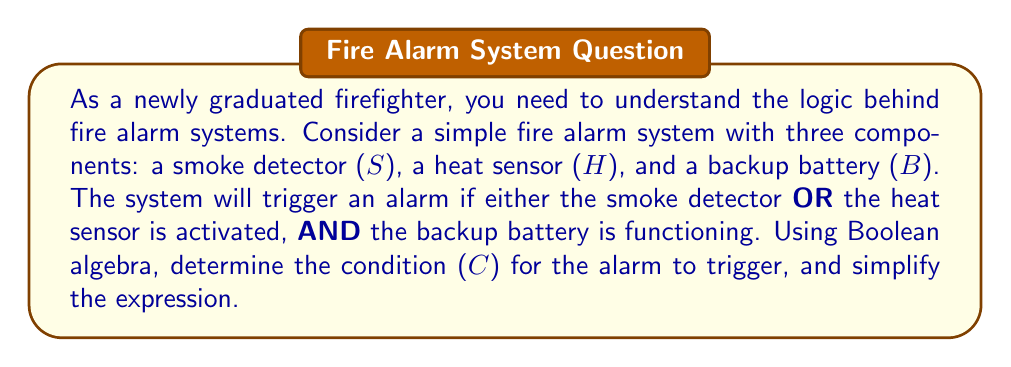Solve this math problem. Let's approach this step-by-step:

1) First, we need to define our Boolean variables:
   $S$: Smoke detector activated (1 if activated, 0 if not)
   $H$: Heat sensor activated (1 if activated, 0 if not)
   $B$: Backup battery functioning (1 if functioning, 0 if not)
   $C$: Condition for alarm to trigger (1 if alarm triggers, 0 if not)

2) The alarm triggers if:
   (Smoke detector OR Heat sensor is activated) AND Backup battery is functioning
   
3) We can express this in Boolean algebra as:
   $C = (S \lor H) \land B$

4) This expression is already in its simplest form, as it accurately represents the logic of the system without any redundant terms.

5) To verify:
   - If $S = 1$, $H = 0$, $B = 1$, then $C = (1 \lor 0) \land 1 = 1 \land 1 = 1$ (Alarm triggers)
   - If $S = 0$, $H = 1$, $B = 1$, then $C = (0 \lor 1) \land 1 = 1 \land 1 = 1$ (Alarm triggers)
   - If $S = 1$, $H = 1$, $B = 0$, then $C = (1 \lor 1) \land 0 = 1 \land 0 = 0$ (Alarm doesn't trigger)
   - If $S = 0$, $H = 0$, $B = 1$, then $C = (0 \lor 0) \land 1 = 0 \land 1 = 0$ (Alarm doesn't trigger)

This Boolean expression accurately represents the functioning of the fire alarm system.
Answer: $C = (S \lor H) \land B$ 